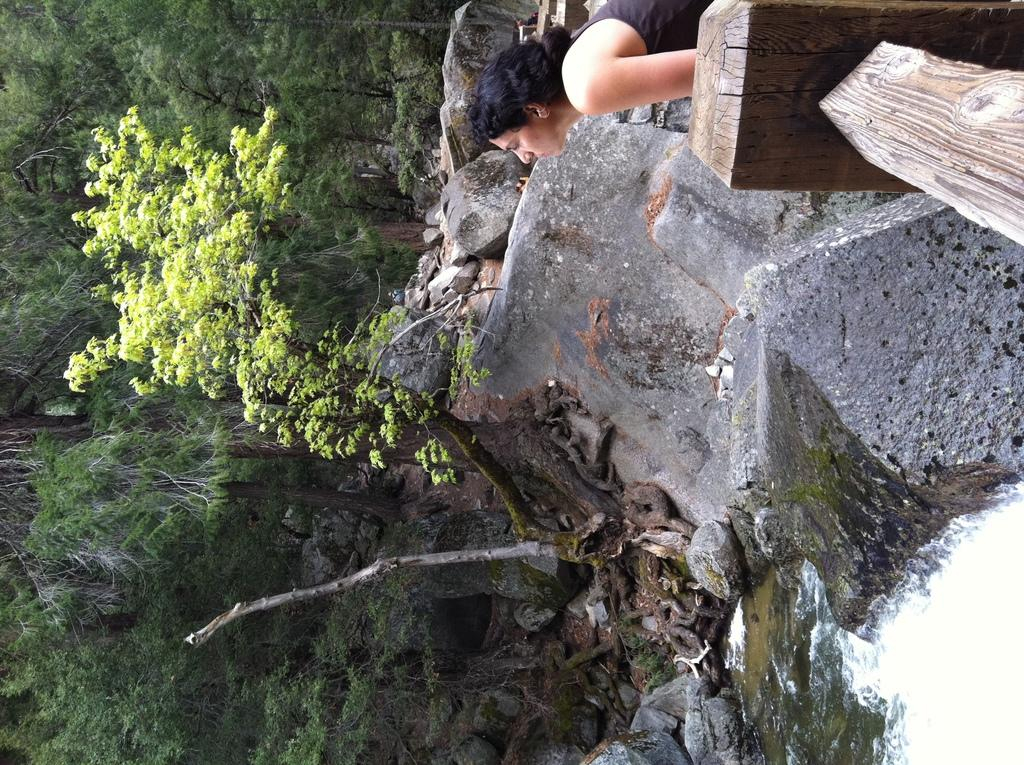What is located in the foreground of the image? There is a pond, a tree, and stones in the foreground of the image. Can you describe the woman's location in the image? The woman is near wooden railing at the top of the image. What can be seen on the left side of the image? There are trees on the left side of the image. What type of box is being used for the flight in the image? There is no box or flight present in the image. How does the woman start her journey in the image? The image does not show the woman starting a journey; she is simply standing near wooden railing. 